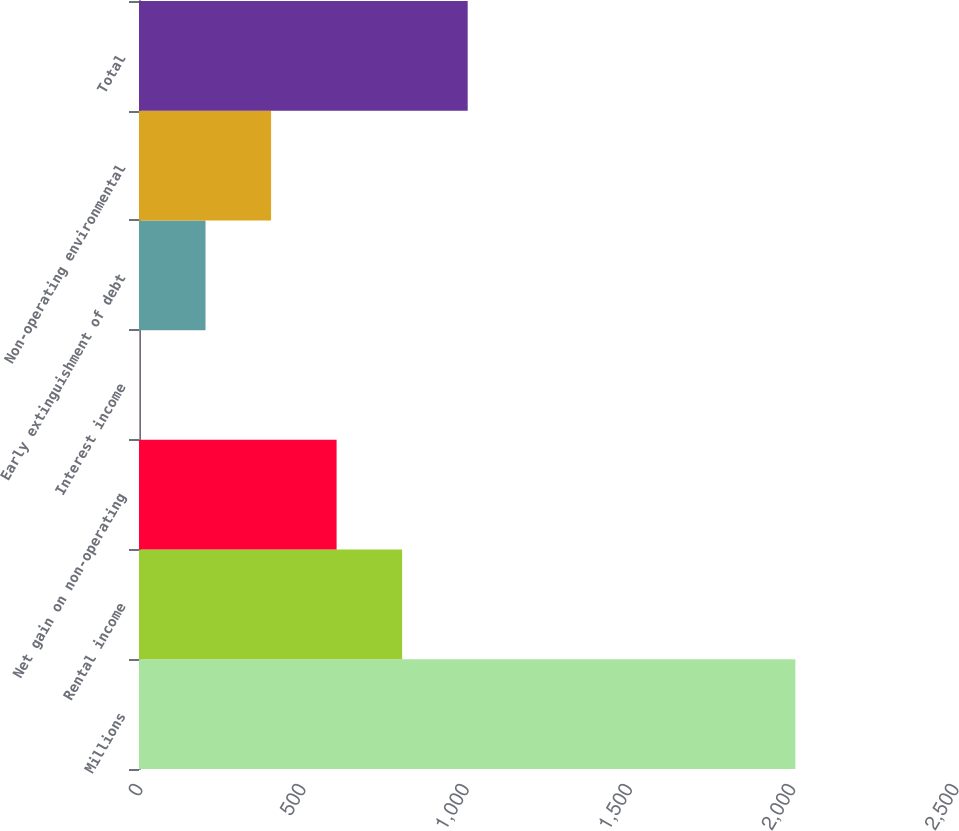Convert chart. <chart><loc_0><loc_0><loc_500><loc_500><bar_chart><fcel>Millions<fcel>Rental income<fcel>Net gain on non-operating<fcel>Interest income<fcel>Early extinguishment of debt<fcel>Non-operating environmental<fcel>Total<nl><fcel>2011<fcel>806.2<fcel>605.4<fcel>3<fcel>203.8<fcel>404.6<fcel>1007<nl></chart> 